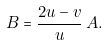<formula> <loc_0><loc_0><loc_500><loc_500>B = \frac { 2 u - v } { u } \, A .</formula> 